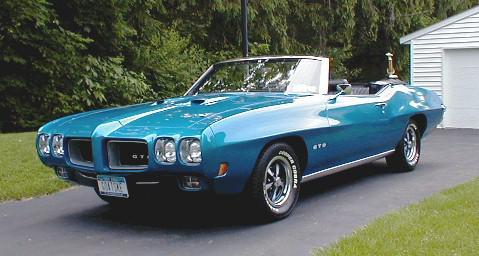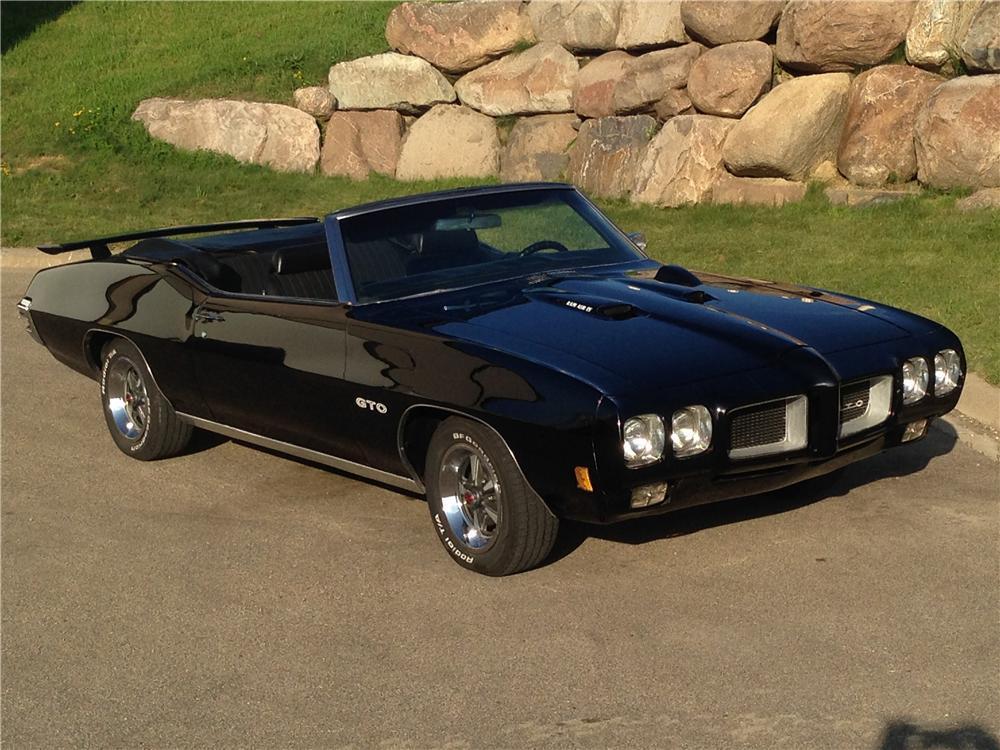The first image is the image on the left, the second image is the image on the right. Analyze the images presented: Is the assertion "At least one car has its top down." valid? Answer yes or no. Yes. 